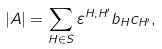<formula> <loc_0><loc_0><loc_500><loc_500>| A | = \sum _ { H \in S } \varepsilon ^ { H , H ^ { \prime } } b _ { H } c _ { H ^ { \prime } } ,</formula> 